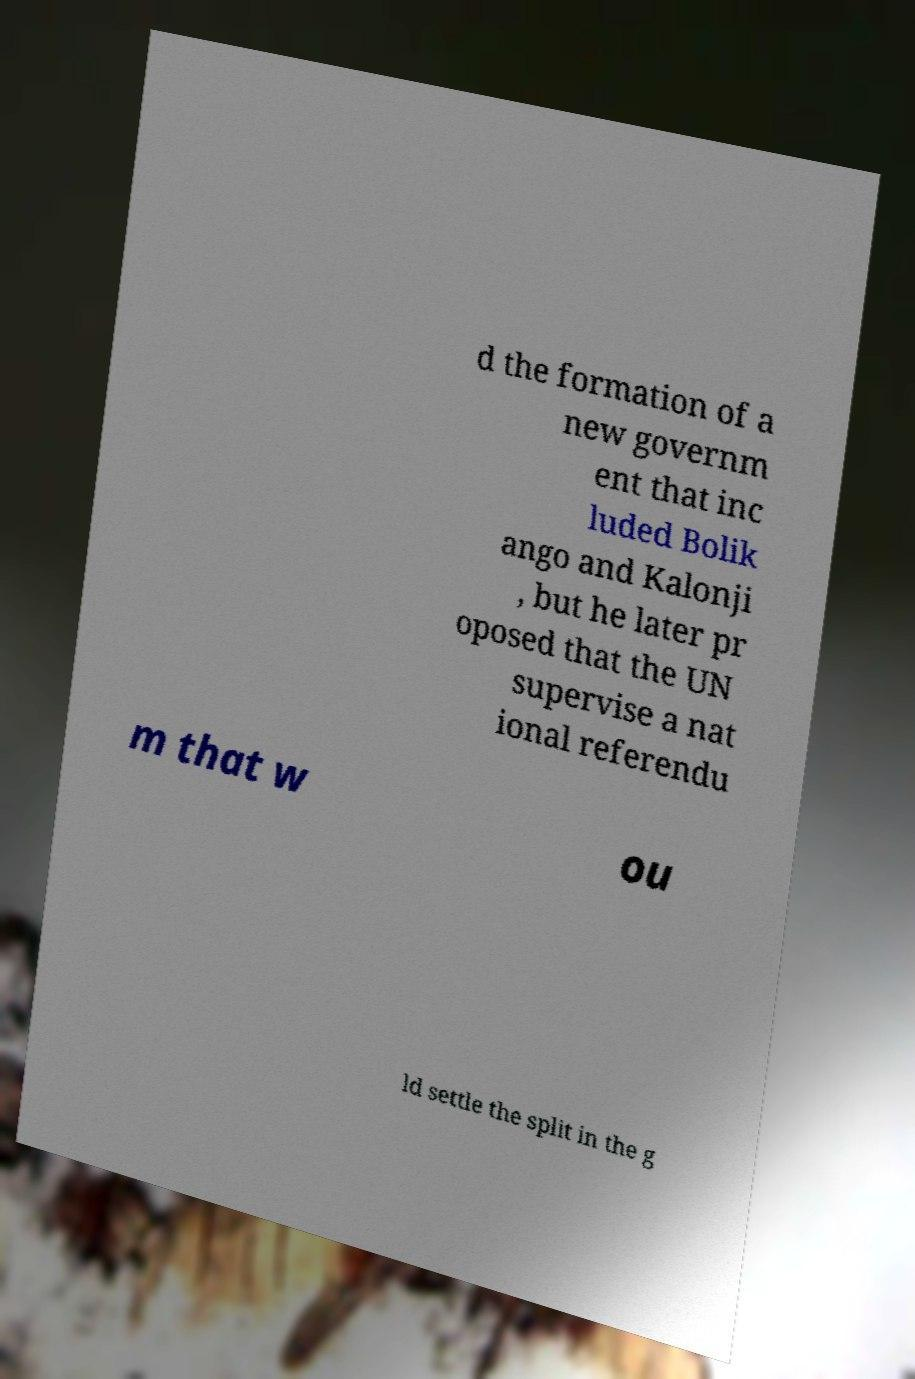Please read and relay the text visible in this image. What does it say? d the formation of a new governm ent that inc luded Bolik ango and Kalonji , but he later pr oposed that the UN supervise a nat ional referendu m that w ou ld settle the split in the g 